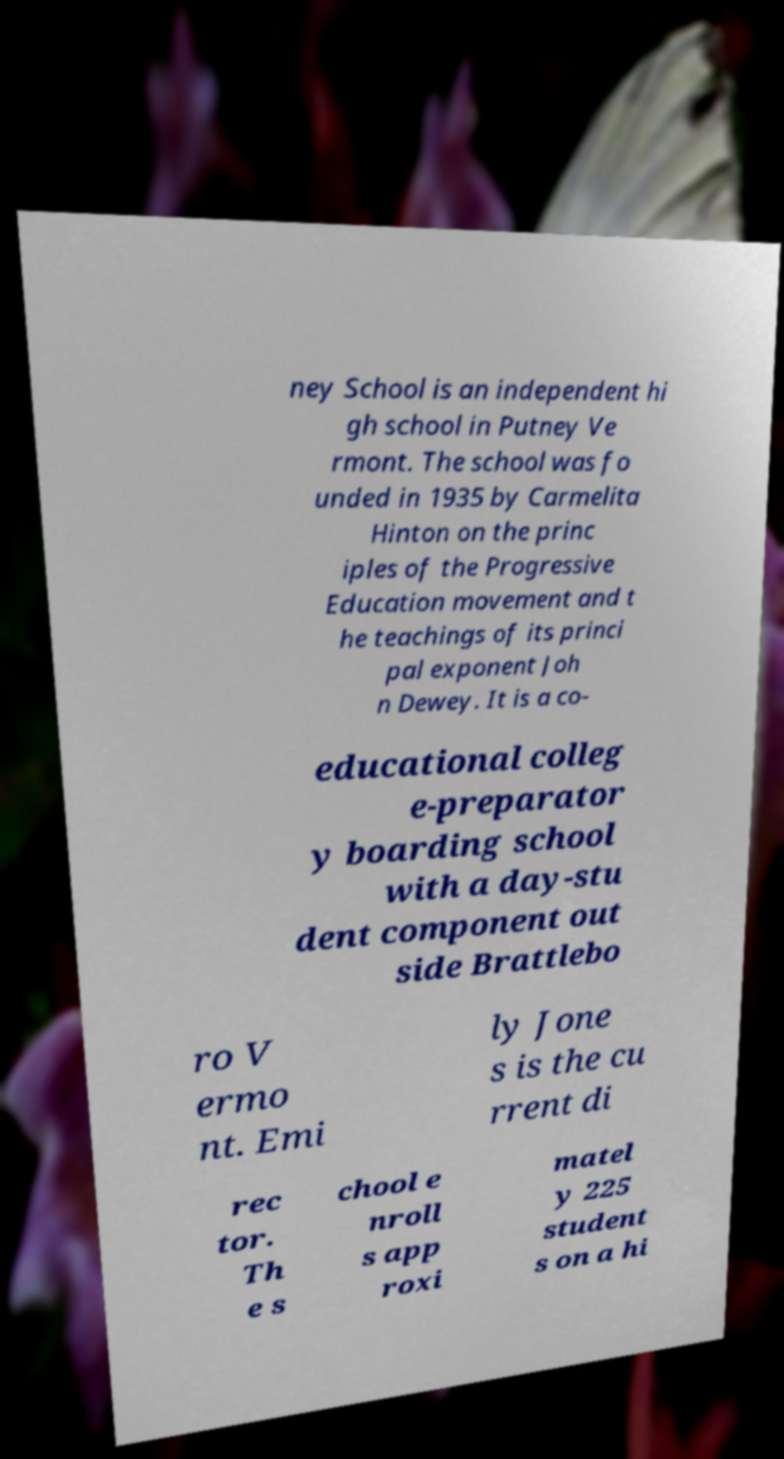For documentation purposes, I need the text within this image transcribed. Could you provide that? ney School is an independent hi gh school in Putney Ve rmont. The school was fo unded in 1935 by Carmelita Hinton on the princ iples of the Progressive Education movement and t he teachings of its princi pal exponent Joh n Dewey. It is a co- educational colleg e-preparator y boarding school with a day-stu dent component out side Brattlebo ro V ermo nt. Emi ly Jone s is the cu rrent di rec tor. Th e s chool e nroll s app roxi matel y 225 student s on a hi 